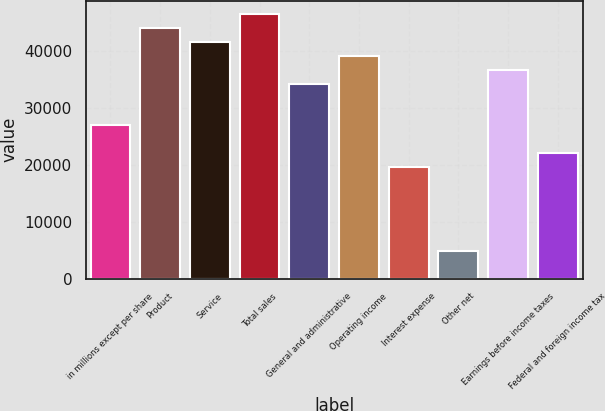Convert chart to OTSL. <chart><loc_0><loc_0><loc_500><loc_500><bar_chart><fcel>in millions except per share<fcel>Product<fcel>Service<fcel>Total sales<fcel>General and administrative<fcel>Operating income<fcel>Interest expense<fcel>Other net<fcel>Earnings before income taxes<fcel>Federal and foreign income tax<nl><fcel>26957.6<fcel>44104.6<fcel>41655.1<fcel>46554.2<fcel>34306.3<fcel>39205.5<fcel>19608.8<fcel>4911.35<fcel>36755.9<fcel>22058.4<nl></chart> 